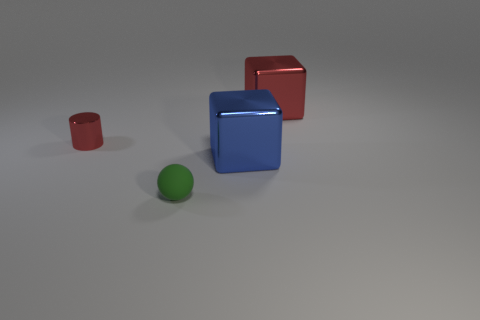What color is the small cylinder?
Ensure brevity in your answer.  Red. What is the shape of the large red thing that is made of the same material as the red cylinder?
Ensure brevity in your answer.  Cube. Does the metallic object that is on the left side of the blue block have the same size as the big red thing?
Make the answer very short. No. How many objects are red objects that are on the right side of the small matte ball or metallic cubes behind the large blue shiny thing?
Your answer should be compact. 1. Is the color of the big metallic block left of the big red shiny object the same as the cylinder?
Your answer should be very brief. No. What number of metal objects are either large objects or large red things?
Offer a very short reply. 2. What is the shape of the small green matte object?
Your response must be concise. Sphere. Is there any other thing that has the same material as the big blue cube?
Your response must be concise. Yes. Are the small green sphere and the big red thing made of the same material?
Provide a succinct answer. No. There is a metallic cube that is in front of the big block behind the small red cylinder; is there a small object that is behind it?
Offer a terse response. Yes. 